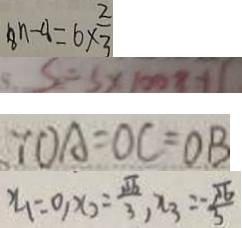<formula> <loc_0><loc_0><loc_500><loc_500>8 n - 4 = 6 \times \frac { 2 } { 3 } 
 S = S \times 1 0 0 8 + 1 
 \because O A = O C = O B 
 x _ { 1 } = 0 , x _ { 2 } = \frac { \sqrt { 6 } } { 3 } , x _ { 3 } = \frac { - \sqrt { 6 } } { 3 }</formula> 